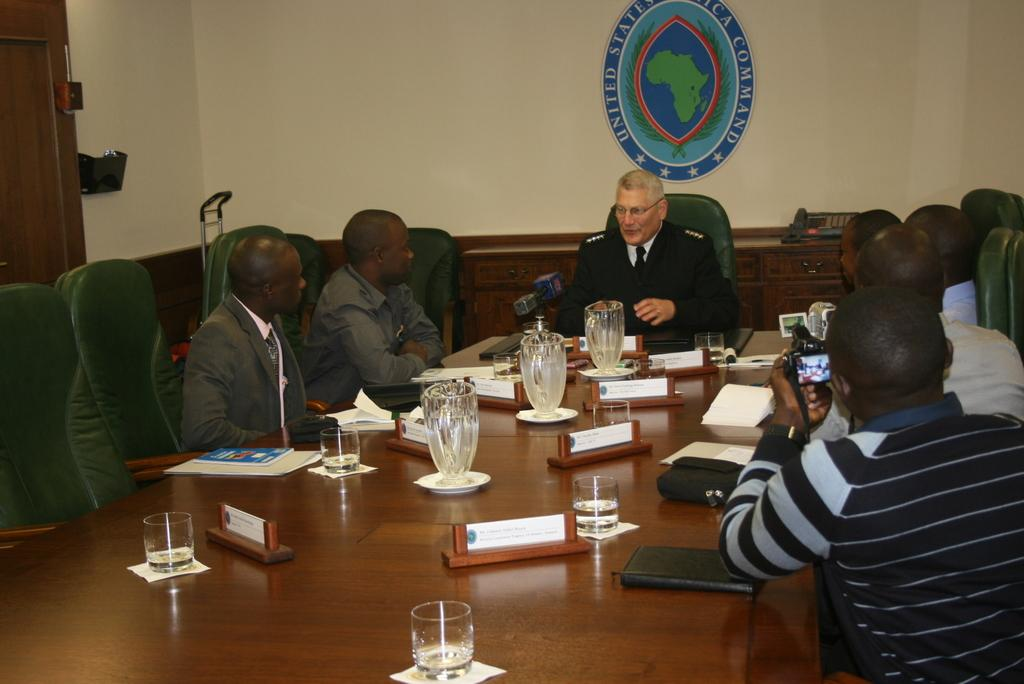What are the people in the image doing? The people are sitting at a table and listening to a middle person talking. What objects are present at the table? There are chairs, glasses, mugs, and books on the table. What might the people be using the glasses and mugs for? The glasses and mugs might be used for drinking. What is the father's opinion on the invention mentioned in the conversation? There is no mention of a father or an invention in the image, so it is impossible to determine their opinions. 